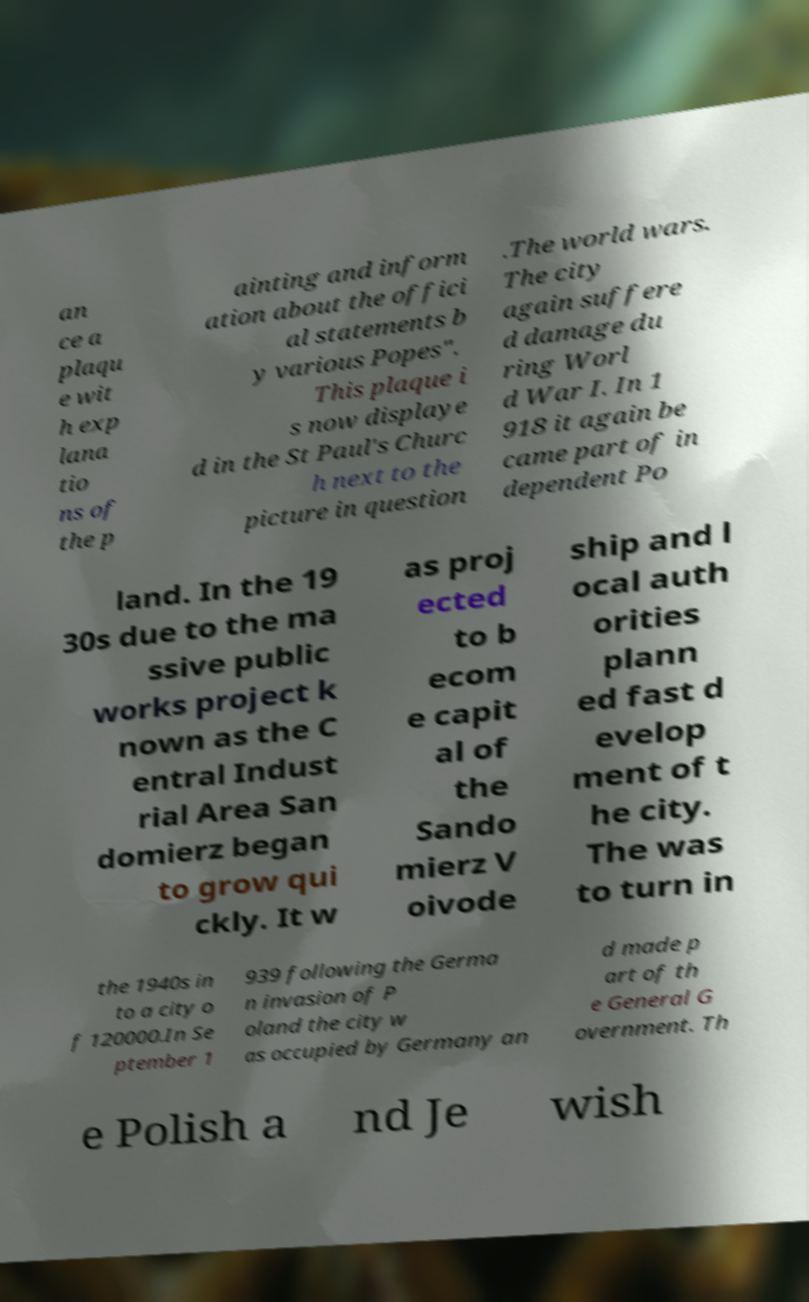For documentation purposes, I need the text within this image transcribed. Could you provide that? an ce a plaqu e wit h exp lana tio ns of the p ainting and inform ation about the offici al statements b y various Popes". This plaque i s now displaye d in the St Paul's Churc h next to the picture in question .The world wars. The city again suffere d damage du ring Worl d War I. In 1 918 it again be came part of in dependent Po land. In the 19 30s due to the ma ssive public works project k nown as the C entral Indust rial Area San domierz began to grow qui ckly. It w as proj ected to b ecom e capit al of the Sando mierz V oivode ship and l ocal auth orities plann ed fast d evelop ment of t he city. The was to turn in the 1940s in to a city o f 120000.In Se ptember 1 939 following the Germa n invasion of P oland the city w as occupied by Germany an d made p art of th e General G overnment. Th e Polish a nd Je wish 